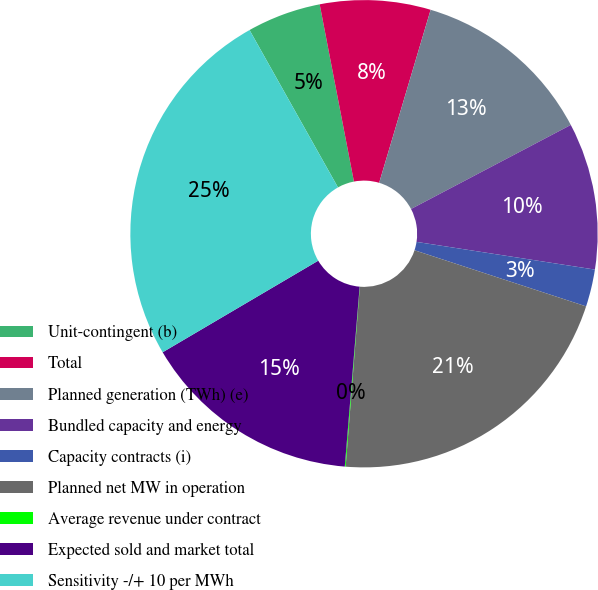<chart> <loc_0><loc_0><loc_500><loc_500><pie_chart><fcel>Unit-contingent (b)<fcel>Total<fcel>Planned generation (TWh) (e)<fcel>Bundled capacity and energy<fcel>Capacity contracts (i)<fcel>Planned net MW in operation<fcel>Average revenue under contract<fcel>Expected sold and market total<fcel>Sensitivity -/+ 10 per MWh<nl><fcel>5.11%<fcel>7.64%<fcel>12.69%<fcel>10.16%<fcel>2.58%<fcel>21.22%<fcel>0.06%<fcel>15.22%<fcel>25.32%<nl></chart> 